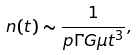Convert formula to latex. <formula><loc_0><loc_0><loc_500><loc_500>n ( t ) \sim \frac { 1 } { p \Gamma G \mu t ^ { 3 } } ,</formula> 